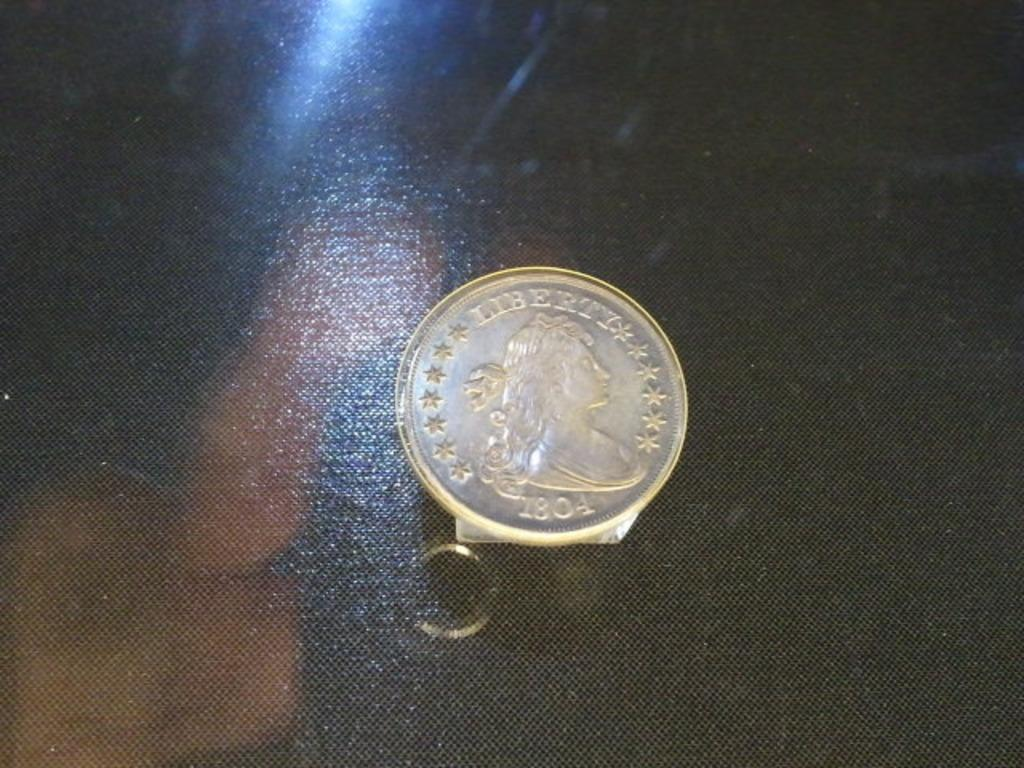Provide a one-sentence caption for the provided image. A silver Liberty coin from 1804 on a table. 